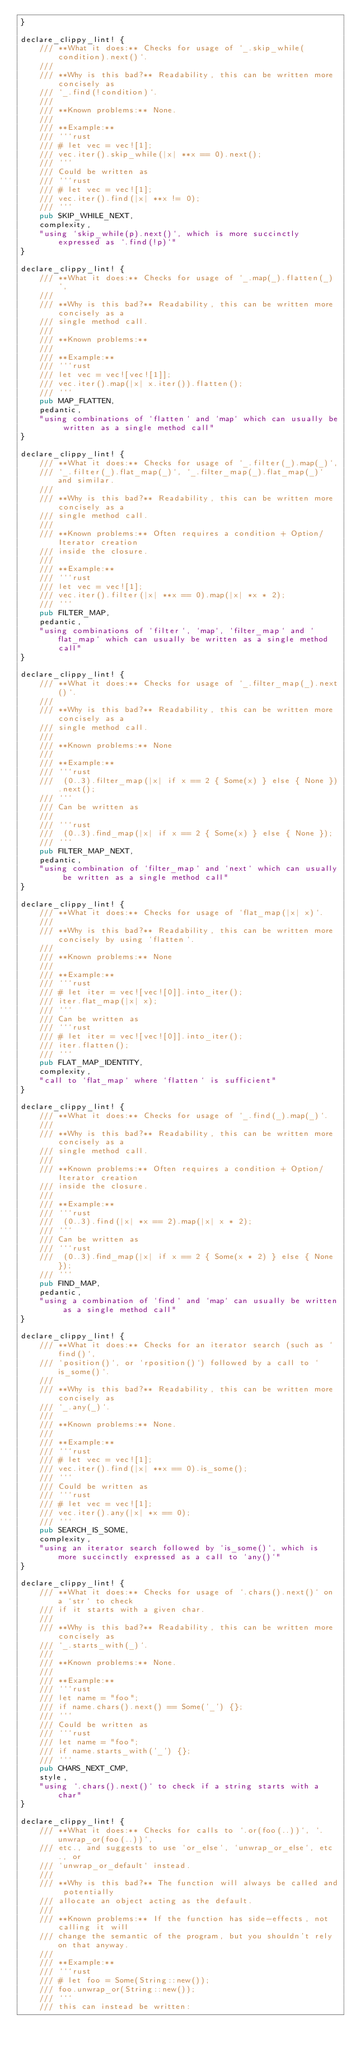Convert code to text. <code><loc_0><loc_0><loc_500><loc_500><_Rust_>}

declare_clippy_lint! {
    /// **What it does:** Checks for usage of `_.skip_while(condition).next()`.
    ///
    /// **Why is this bad?** Readability, this can be written more concisely as
    /// `_.find(!condition)`.
    ///
    /// **Known problems:** None.
    ///
    /// **Example:**
    /// ```rust
    /// # let vec = vec![1];
    /// vec.iter().skip_while(|x| **x == 0).next();
    /// ```
    /// Could be written as
    /// ```rust
    /// # let vec = vec![1];
    /// vec.iter().find(|x| **x != 0);
    /// ```
    pub SKIP_WHILE_NEXT,
    complexity,
    "using `skip_while(p).next()`, which is more succinctly expressed as `.find(!p)`"
}

declare_clippy_lint! {
    /// **What it does:** Checks for usage of `_.map(_).flatten(_)`,
    ///
    /// **Why is this bad?** Readability, this can be written more concisely as a
    /// single method call.
    ///
    /// **Known problems:**
    ///
    /// **Example:**
    /// ```rust
    /// let vec = vec![vec![1]];
    /// vec.iter().map(|x| x.iter()).flatten();
    /// ```
    pub MAP_FLATTEN,
    pedantic,
    "using combinations of `flatten` and `map` which can usually be written as a single method call"
}

declare_clippy_lint! {
    /// **What it does:** Checks for usage of `_.filter(_).map(_)`,
    /// `_.filter(_).flat_map(_)`, `_.filter_map(_).flat_map(_)` and similar.
    ///
    /// **Why is this bad?** Readability, this can be written more concisely as a
    /// single method call.
    ///
    /// **Known problems:** Often requires a condition + Option/Iterator creation
    /// inside the closure.
    ///
    /// **Example:**
    /// ```rust
    /// let vec = vec![1];
    /// vec.iter().filter(|x| **x == 0).map(|x| *x * 2);
    /// ```
    pub FILTER_MAP,
    pedantic,
    "using combinations of `filter`, `map`, `filter_map` and `flat_map` which can usually be written as a single method call"
}

declare_clippy_lint! {
    /// **What it does:** Checks for usage of `_.filter_map(_).next()`.
    ///
    /// **Why is this bad?** Readability, this can be written more concisely as a
    /// single method call.
    ///
    /// **Known problems:** None
    ///
    /// **Example:**
    /// ```rust
    ///  (0..3).filter_map(|x| if x == 2 { Some(x) } else { None }).next();
    /// ```
    /// Can be written as
    ///
    /// ```rust
    ///  (0..3).find_map(|x| if x == 2 { Some(x) } else { None });
    /// ```
    pub FILTER_MAP_NEXT,
    pedantic,
    "using combination of `filter_map` and `next` which can usually be written as a single method call"
}

declare_clippy_lint! {
    /// **What it does:** Checks for usage of `flat_map(|x| x)`.
    ///
    /// **Why is this bad?** Readability, this can be written more concisely by using `flatten`.
    ///
    /// **Known problems:** None
    ///
    /// **Example:**
    /// ```rust
    /// # let iter = vec![vec![0]].into_iter();
    /// iter.flat_map(|x| x);
    /// ```
    /// Can be written as
    /// ```rust
    /// # let iter = vec![vec![0]].into_iter();
    /// iter.flatten();
    /// ```
    pub FLAT_MAP_IDENTITY,
    complexity,
    "call to `flat_map` where `flatten` is sufficient"
}

declare_clippy_lint! {
    /// **What it does:** Checks for usage of `_.find(_).map(_)`.
    ///
    /// **Why is this bad?** Readability, this can be written more concisely as a
    /// single method call.
    ///
    /// **Known problems:** Often requires a condition + Option/Iterator creation
    /// inside the closure.
    ///
    /// **Example:**
    /// ```rust
    ///  (0..3).find(|x| *x == 2).map(|x| x * 2);
    /// ```
    /// Can be written as
    /// ```rust
    ///  (0..3).find_map(|x| if x == 2 { Some(x * 2) } else { None });
    /// ```
    pub FIND_MAP,
    pedantic,
    "using a combination of `find` and `map` can usually be written as a single method call"
}

declare_clippy_lint! {
    /// **What it does:** Checks for an iterator search (such as `find()`,
    /// `position()`, or `rposition()`) followed by a call to `is_some()`.
    ///
    /// **Why is this bad?** Readability, this can be written more concisely as
    /// `_.any(_)`.
    ///
    /// **Known problems:** None.
    ///
    /// **Example:**
    /// ```rust
    /// # let vec = vec![1];
    /// vec.iter().find(|x| **x == 0).is_some();
    /// ```
    /// Could be written as
    /// ```rust
    /// # let vec = vec![1];
    /// vec.iter().any(|x| *x == 0);
    /// ```
    pub SEARCH_IS_SOME,
    complexity,
    "using an iterator search followed by `is_some()`, which is more succinctly expressed as a call to `any()`"
}

declare_clippy_lint! {
    /// **What it does:** Checks for usage of `.chars().next()` on a `str` to check
    /// if it starts with a given char.
    ///
    /// **Why is this bad?** Readability, this can be written more concisely as
    /// `_.starts_with(_)`.
    ///
    /// **Known problems:** None.
    ///
    /// **Example:**
    /// ```rust
    /// let name = "foo";
    /// if name.chars().next() == Some('_') {};
    /// ```
    /// Could be written as
    /// ```rust
    /// let name = "foo";
    /// if name.starts_with('_') {};
    /// ```
    pub CHARS_NEXT_CMP,
    style,
    "using `.chars().next()` to check if a string starts with a char"
}

declare_clippy_lint! {
    /// **What it does:** Checks for calls to `.or(foo(..))`, `.unwrap_or(foo(..))`,
    /// etc., and suggests to use `or_else`, `unwrap_or_else`, etc., or
    /// `unwrap_or_default` instead.
    ///
    /// **Why is this bad?** The function will always be called and potentially
    /// allocate an object acting as the default.
    ///
    /// **Known problems:** If the function has side-effects, not calling it will
    /// change the semantic of the program, but you shouldn't rely on that anyway.
    ///
    /// **Example:**
    /// ```rust
    /// # let foo = Some(String::new());
    /// foo.unwrap_or(String::new());
    /// ```
    /// this can instead be written:</code> 